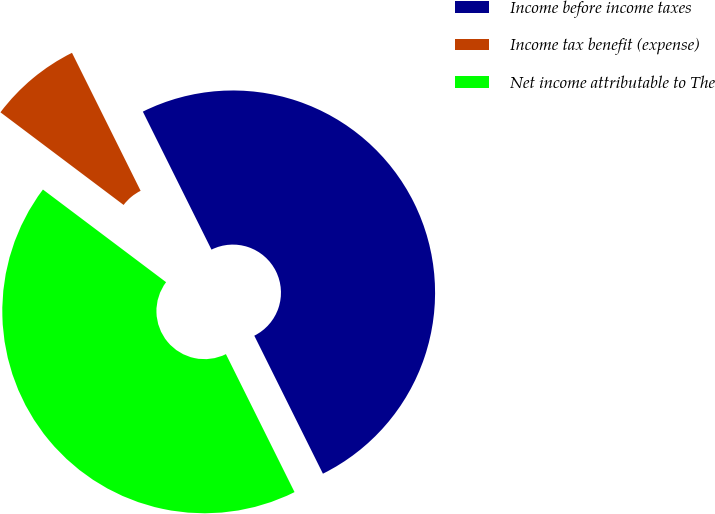Convert chart to OTSL. <chart><loc_0><loc_0><loc_500><loc_500><pie_chart><fcel>Income before income taxes<fcel>Income tax benefit (expense)<fcel>Net income attributable to The<nl><fcel>50.0%<fcel>7.39%<fcel>42.61%<nl></chart> 